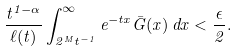<formula> <loc_0><loc_0><loc_500><loc_500>\frac { t ^ { 1 - \alpha } } { \ell ( t ) } \int _ { 2 ^ { M } t ^ { - 1 } } ^ { \infty } e ^ { - t x } { \bar { G } } ( x ) \, d x < \frac { \epsilon } { 2 } .</formula> 